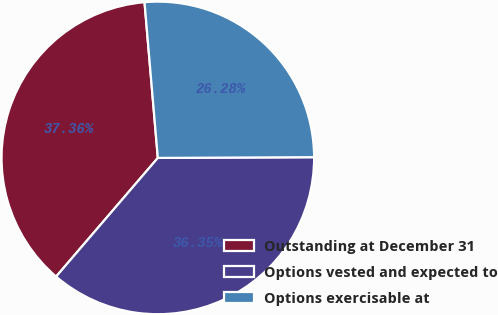<chart> <loc_0><loc_0><loc_500><loc_500><pie_chart><fcel>Outstanding at December 31<fcel>Options vested and expected to<fcel>Options exercisable at<nl><fcel>37.36%<fcel>36.35%<fcel>26.28%<nl></chart> 